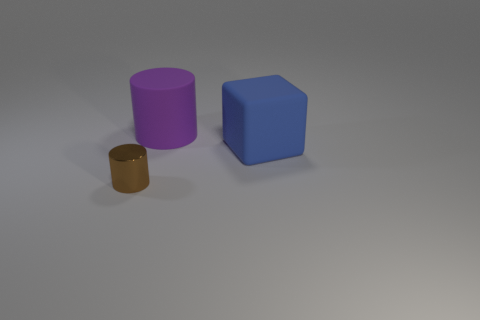Is the number of small shiny things that are behind the rubber cylinder greater than the number of blue rubber blocks?
Your response must be concise. No. There is a matte thing on the right side of the matte thing behind the rubber cube; how many big purple rubber cylinders are right of it?
Make the answer very short. 0. There is a thing left of the big cylinder; is its shape the same as the purple rubber thing?
Ensure brevity in your answer.  Yes. There is a thing in front of the big blue block; what is its material?
Offer a terse response. Metal. There is a thing that is in front of the large purple matte cylinder and left of the blue cube; what shape is it?
Provide a short and direct response. Cylinder. What material is the brown cylinder?
Offer a very short reply. Metal. What number of cubes are either blue things or large purple matte objects?
Keep it short and to the point. 1. Are the small brown object and the blue block made of the same material?
Your answer should be very brief. No. There is another thing that is the same shape as the purple matte object; what is its size?
Keep it short and to the point. Small. The object that is behind the tiny cylinder and on the left side of the blue matte cube is made of what material?
Provide a succinct answer. Rubber. 